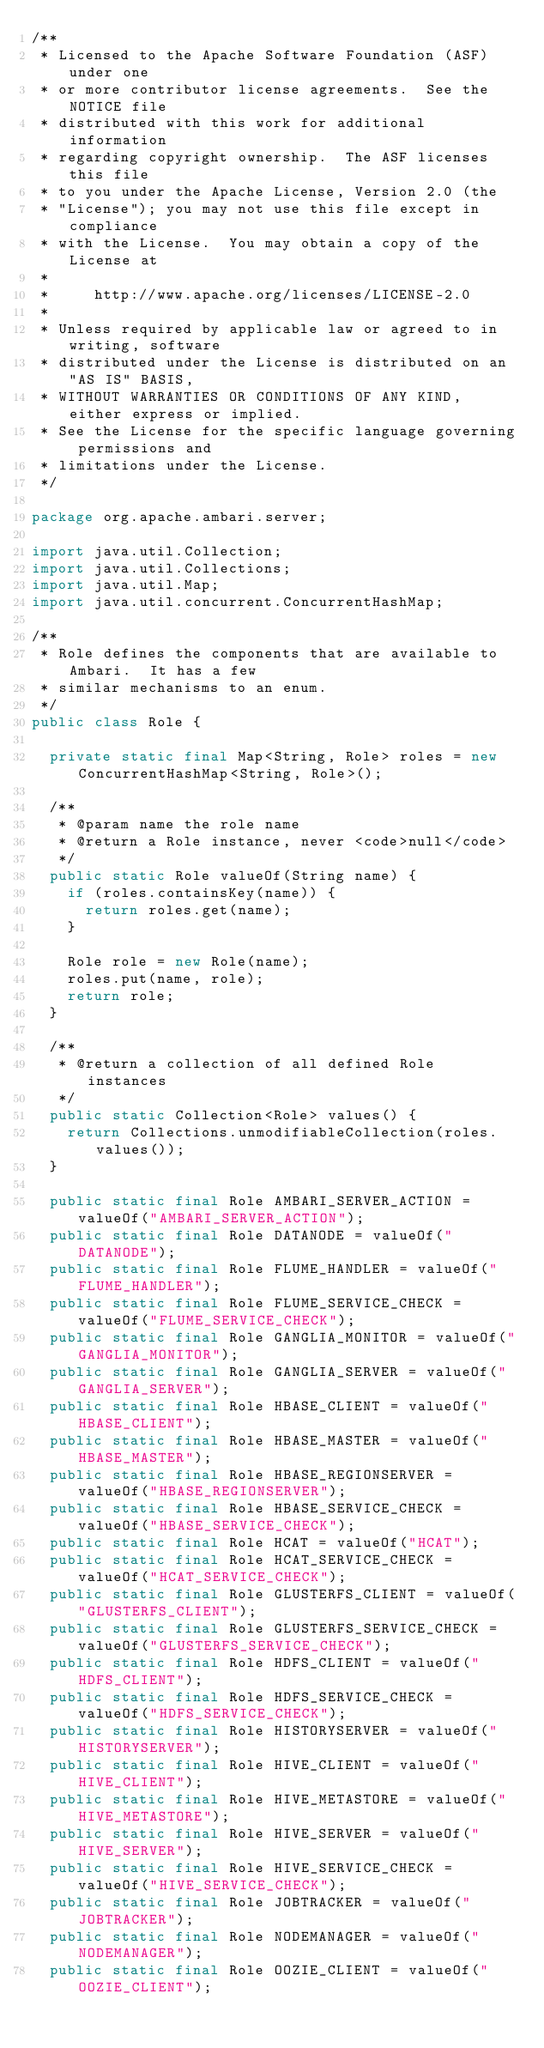<code> <loc_0><loc_0><loc_500><loc_500><_Java_>/**
 * Licensed to the Apache Software Foundation (ASF) under one
 * or more contributor license agreements.  See the NOTICE file
 * distributed with this work for additional information
 * regarding copyright ownership.  The ASF licenses this file
 * to you under the Apache License, Version 2.0 (the
 * "License"); you may not use this file except in compliance
 * with the License.  You may obtain a copy of the License at
 *
 *     http://www.apache.org/licenses/LICENSE-2.0
 *
 * Unless required by applicable law or agreed to in writing, software
 * distributed under the License is distributed on an "AS IS" BASIS,
 * WITHOUT WARRANTIES OR CONDITIONS OF ANY KIND, either express or implied.
 * See the License for the specific language governing permissions and
 * limitations under the License.
 */

package org.apache.ambari.server;

import java.util.Collection;
import java.util.Collections;
import java.util.Map;
import java.util.concurrent.ConcurrentHashMap;

/**
 * Role defines the components that are available to Ambari.  It has a few
 * similar mechanisms to an enum.
 */
public class Role {

  private static final Map<String, Role> roles = new ConcurrentHashMap<String, Role>();

  /**
   * @param name the role name
   * @return a Role instance, never <code>null</code>
   */
  public static Role valueOf(String name) {
    if (roles.containsKey(name)) {
      return roles.get(name);
    }

    Role role = new Role(name);
    roles.put(name, role);
    return role;
  }

  /**
   * @return a collection of all defined Role instances
   */
  public static Collection<Role> values() {
    return Collections.unmodifiableCollection(roles.values());
  }

  public static final Role AMBARI_SERVER_ACTION = valueOf("AMBARI_SERVER_ACTION");
  public static final Role DATANODE = valueOf("DATANODE");
  public static final Role FLUME_HANDLER = valueOf("FLUME_HANDLER");
  public static final Role FLUME_SERVICE_CHECK = valueOf("FLUME_SERVICE_CHECK");
  public static final Role GANGLIA_MONITOR = valueOf("GANGLIA_MONITOR");
  public static final Role GANGLIA_SERVER = valueOf("GANGLIA_SERVER");
  public static final Role HBASE_CLIENT = valueOf("HBASE_CLIENT");
  public static final Role HBASE_MASTER = valueOf("HBASE_MASTER");
  public static final Role HBASE_REGIONSERVER = valueOf("HBASE_REGIONSERVER");
  public static final Role HBASE_SERVICE_CHECK = valueOf("HBASE_SERVICE_CHECK");
  public static final Role HCAT = valueOf("HCAT");
  public static final Role HCAT_SERVICE_CHECK = valueOf("HCAT_SERVICE_CHECK");
  public static final Role GLUSTERFS_CLIENT = valueOf("GLUSTERFS_CLIENT");
  public static final Role GLUSTERFS_SERVICE_CHECK = valueOf("GLUSTERFS_SERVICE_CHECK");
  public static final Role HDFS_CLIENT = valueOf("HDFS_CLIENT");
  public static final Role HDFS_SERVICE_CHECK = valueOf("HDFS_SERVICE_CHECK");
  public static final Role HISTORYSERVER = valueOf("HISTORYSERVER");
  public static final Role HIVE_CLIENT = valueOf("HIVE_CLIENT");
  public static final Role HIVE_METASTORE = valueOf("HIVE_METASTORE");
  public static final Role HIVE_SERVER = valueOf("HIVE_SERVER");
  public static final Role HIVE_SERVICE_CHECK = valueOf("HIVE_SERVICE_CHECK");
  public static final Role JOBTRACKER = valueOf("JOBTRACKER");
  public static final Role NODEMANAGER = valueOf("NODEMANAGER");
  public static final Role OOZIE_CLIENT = valueOf("OOZIE_CLIENT");</code> 